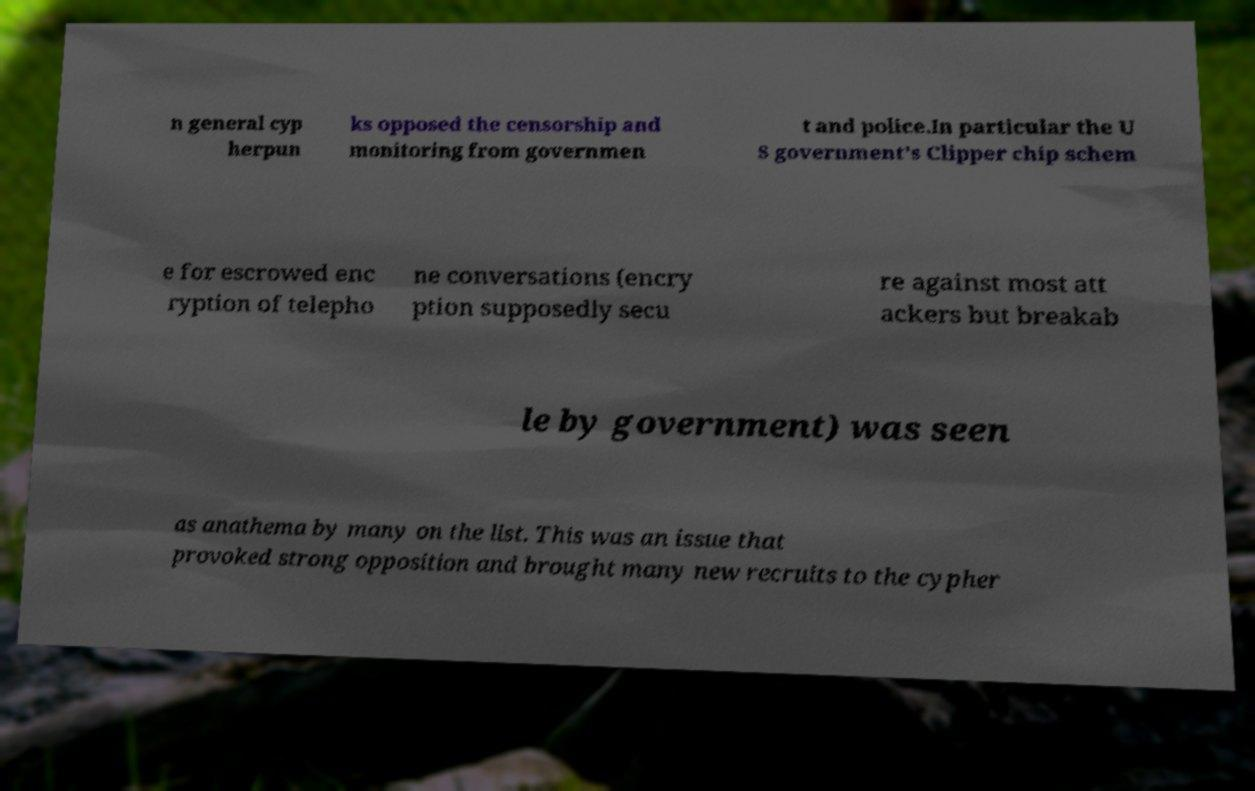Could you extract and type out the text from this image? n general cyp herpun ks opposed the censorship and monitoring from governmen t and police.In particular the U S government's Clipper chip schem e for escrowed enc ryption of telepho ne conversations (encry ption supposedly secu re against most att ackers but breakab le by government) was seen as anathema by many on the list. This was an issue that provoked strong opposition and brought many new recruits to the cypher 